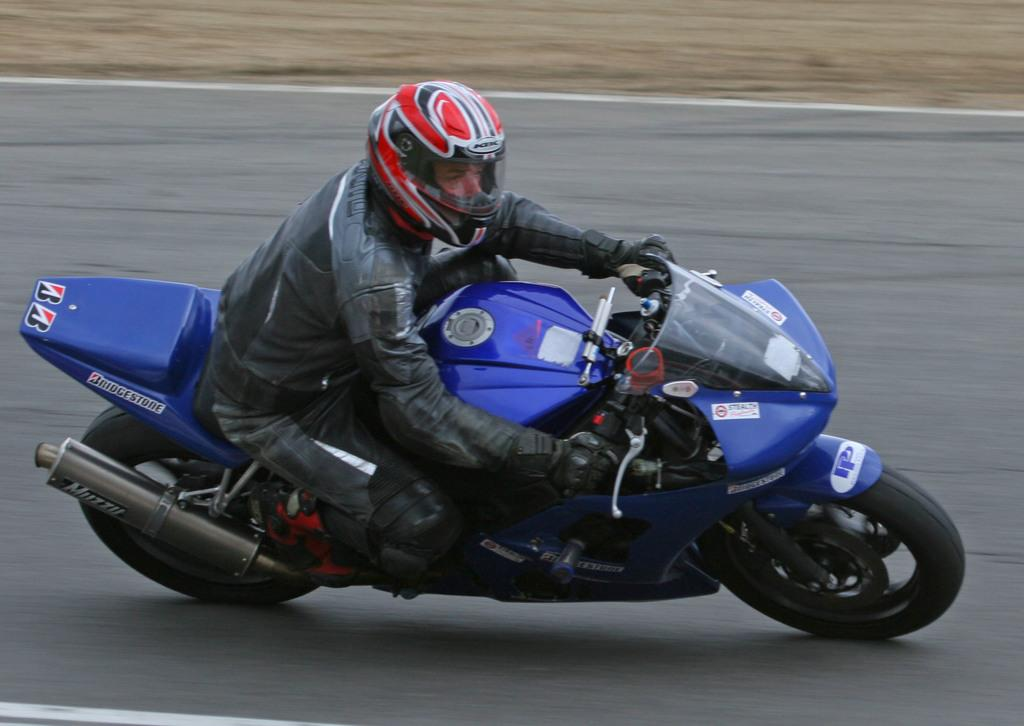Who is the person in the image? There is a man in the image. What is the man doing in the image? The man is riding a bike in the image. Where is the bike located? The bike is on a road in the image. How much sugar is in the net on the side of the road in the image? There is no net or sugar present in the image; it features a man riding a bike on a road. 